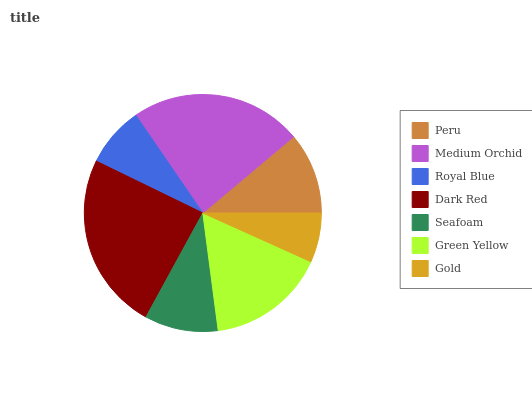Is Gold the minimum?
Answer yes or no. Yes. Is Dark Red the maximum?
Answer yes or no. Yes. Is Medium Orchid the minimum?
Answer yes or no. No. Is Medium Orchid the maximum?
Answer yes or no. No. Is Medium Orchid greater than Peru?
Answer yes or no. Yes. Is Peru less than Medium Orchid?
Answer yes or no. Yes. Is Peru greater than Medium Orchid?
Answer yes or no. No. Is Medium Orchid less than Peru?
Answer yes or no. No. Is Peru the high median?
Answer yes or no. Yes. Is Peru the low median?
Answer yes or no. Yes. Is Medium Orchid the high median?
Answer yes or no. No. Is Dark Red the low median?
Answer yes or no. No. 